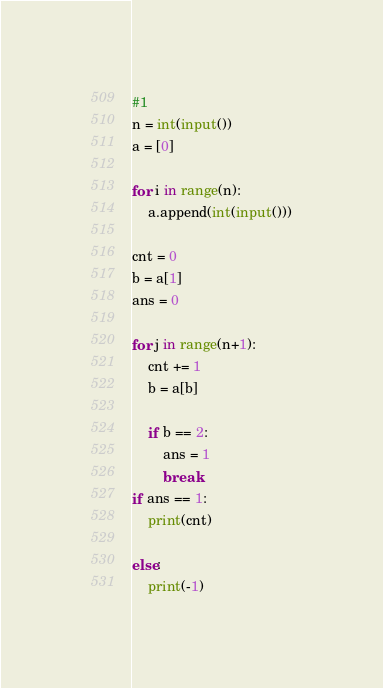Convert code to text. <code><loc_0><loc_0><loc_500><loc_500><_Python_>#1
n = int(input())
a = [0]

for i in range(n):
    a.append(int(input()))

cnt = 0
b = a[1]
ans = 0

for j in range(n+1):
    cnt += 1
    b = a[b]
    
    if b == 2:
        ans = 1
        break
if ans == 1:
    print(cnt)

else:
    print(-1)
</code> 